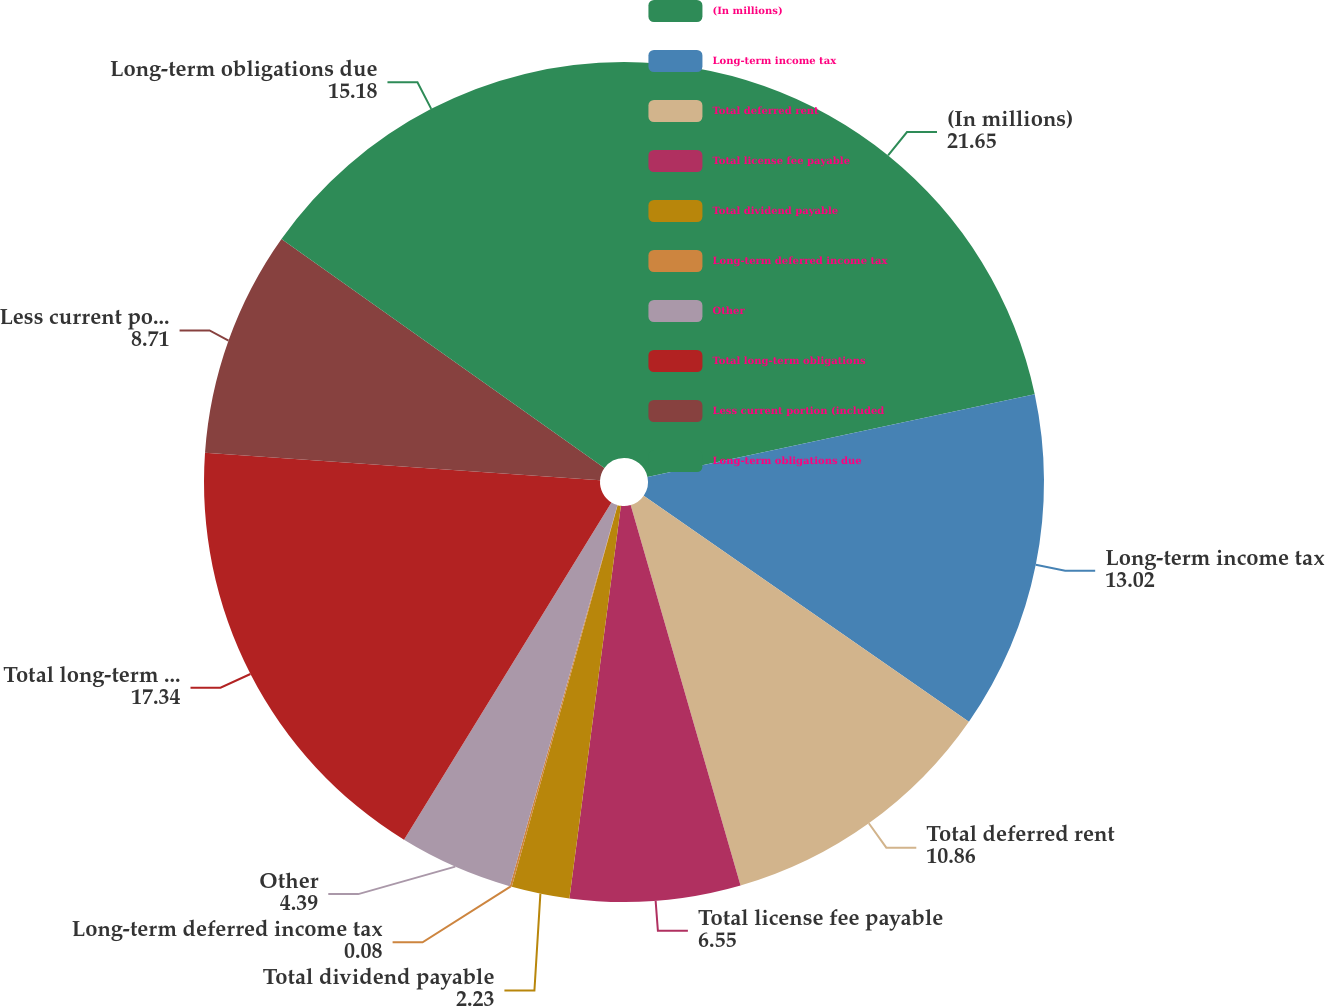<chart> <loc_0><loc_0><loc_500><loc_500><pie_chart><fcel>(In millions)<fcel>Long-term income tax<fcel>Total deferred rent<fcel>Total license fee payable<fcel>Total dividend payable<fcel>Long-term deferred income tax<fcel>Other<fcel>Total long-term obligations<fcel>Less current portion (included<fcel>Long-term obligations due<nl><fcel>21.65%<fcel>13.02%<fcel>10.86%<fcel>6.55%<fcel>2.23%<fcel>0.08%<fcel>4.39%<fcel>17.34%<fcel>8.71%<fcel>15.18%<nl></chart> 